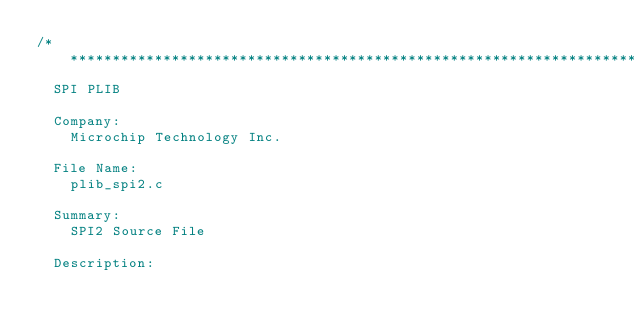Convert code to text. <code><loc_0><loc_0><loc_500><loc_500><_C_>/*******************************************************************************
  SPI PLIB

  Company:
    Microchip Technology Inc.

  File Name:
    plib_spi2.c

  Summary:
    SPI2 Source File

  Description:</code> 